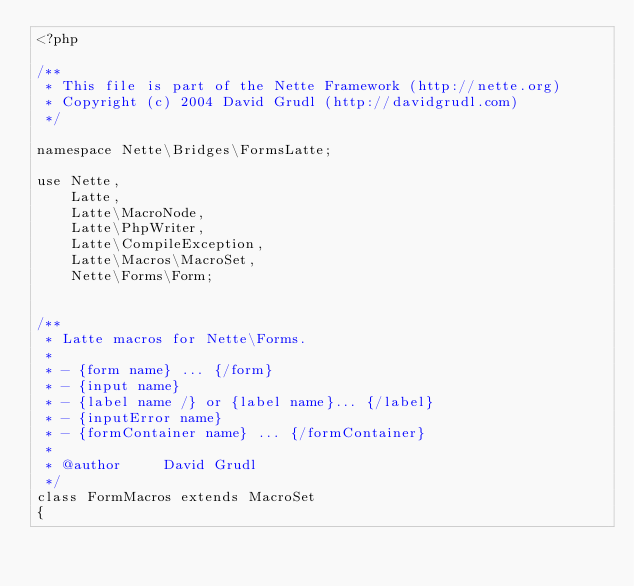Convert code to text. <code><loc_0><loc_0><loc_500><loc_500><_PHP_><?php

/**
 * This file is part of the Nette Framework (http://nette.org)
 * Copyright (c) 2004 David Grudl (http://davidgrudl.com)
 */

namespace Nette\Bridges\FormsLatte;

use Nette,
	Latte,
	Latte\MacroNode,
	Latte\PhpWriter,
	Latte\CompileException,
	Latte\Macros\MacroSet,
	Nette\Forms\Form;


/**
 * Latte macros for Nette\Forms.
 *
 * - {form name} ... {/form}
 * - {input name}
 * - {label name /} or {label name}... {/label}
 * - {inputError name}
 * - {formContainer name} ... {/formContainer}
 *
 * @author     David Grudl
 */
class FormMacros extends MacroSet
{
</code> 